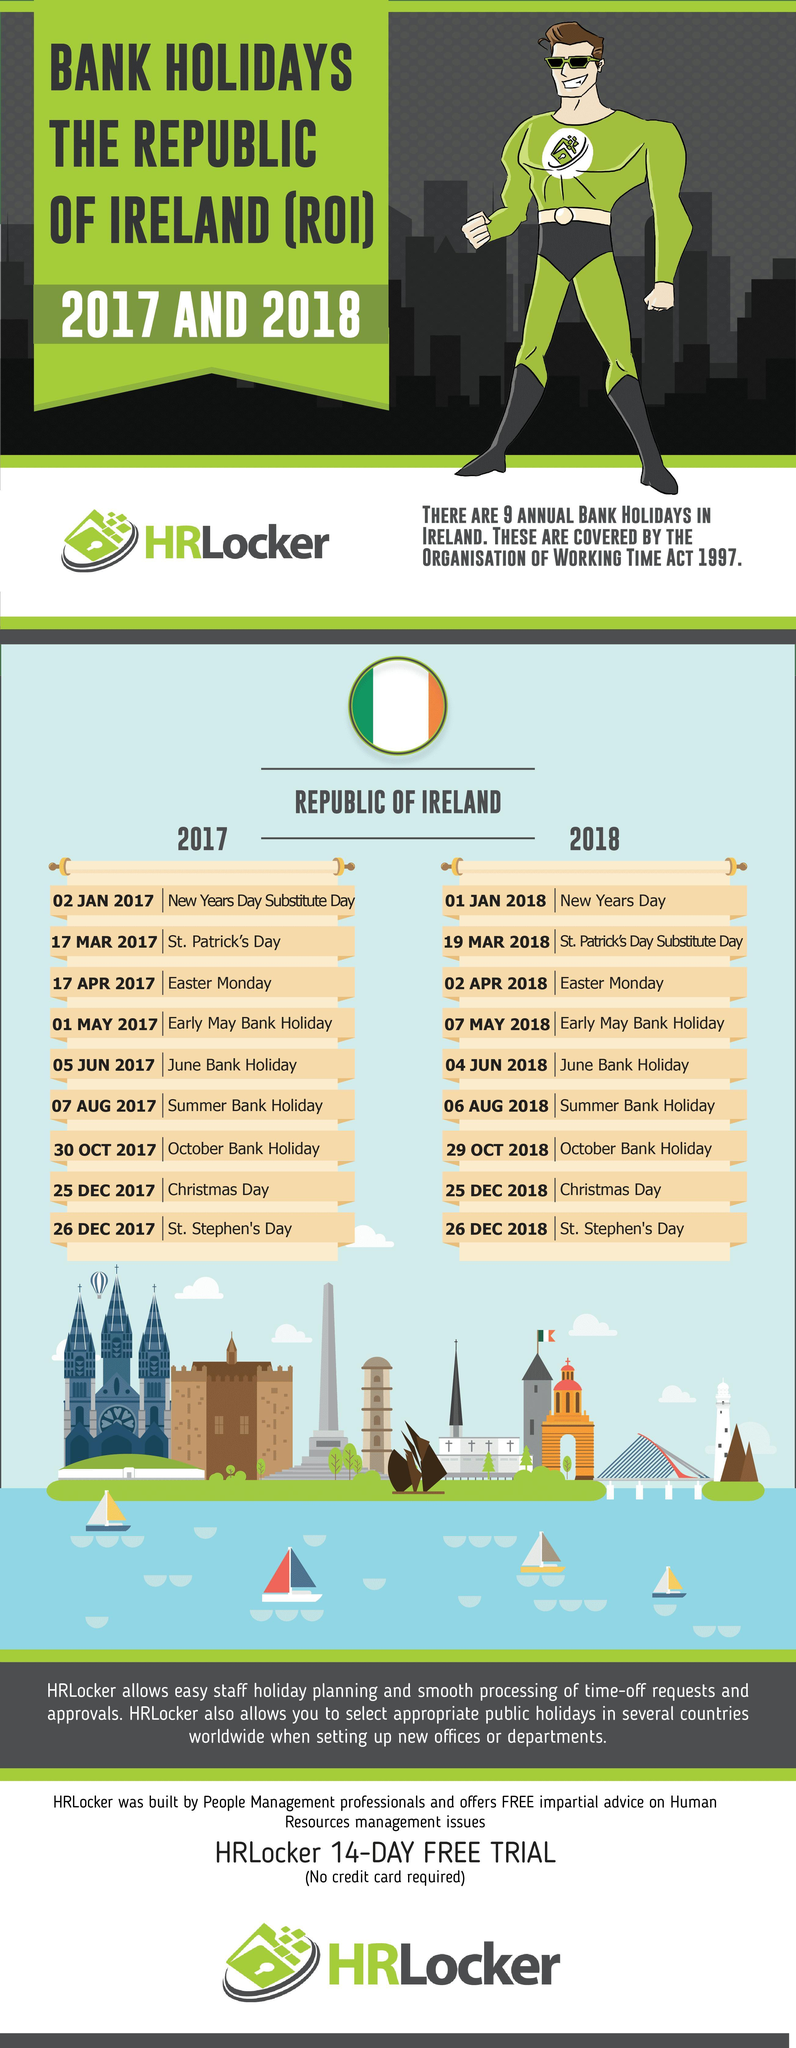which are the days common in both 2017 and 2018 bank holidays?
Answer the question with a short phrase. 25 DEC, 26 DEC which are the three colors in the flag of republic or Ireland among black, blue, green, white and orange?? green, white, orange how many sailing boats are there in the vector image? 4 How many bank holidays are there in December 2018? 2 How many months are there without bank holidays in 2017 according to the list? 4 